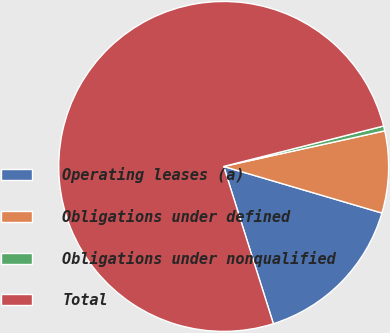<chart> <loc_0><loc_0><loc_500><loc_500><pie_chart><fcel>Operating leases (a)<fcel>Obligations under defined<fcel>Obligations under nonqualified<fcel>Total<nl><fcel>15.57%<fcel>8.02%<fcel>0.48%<fcel>75.93%<nl></chart> 